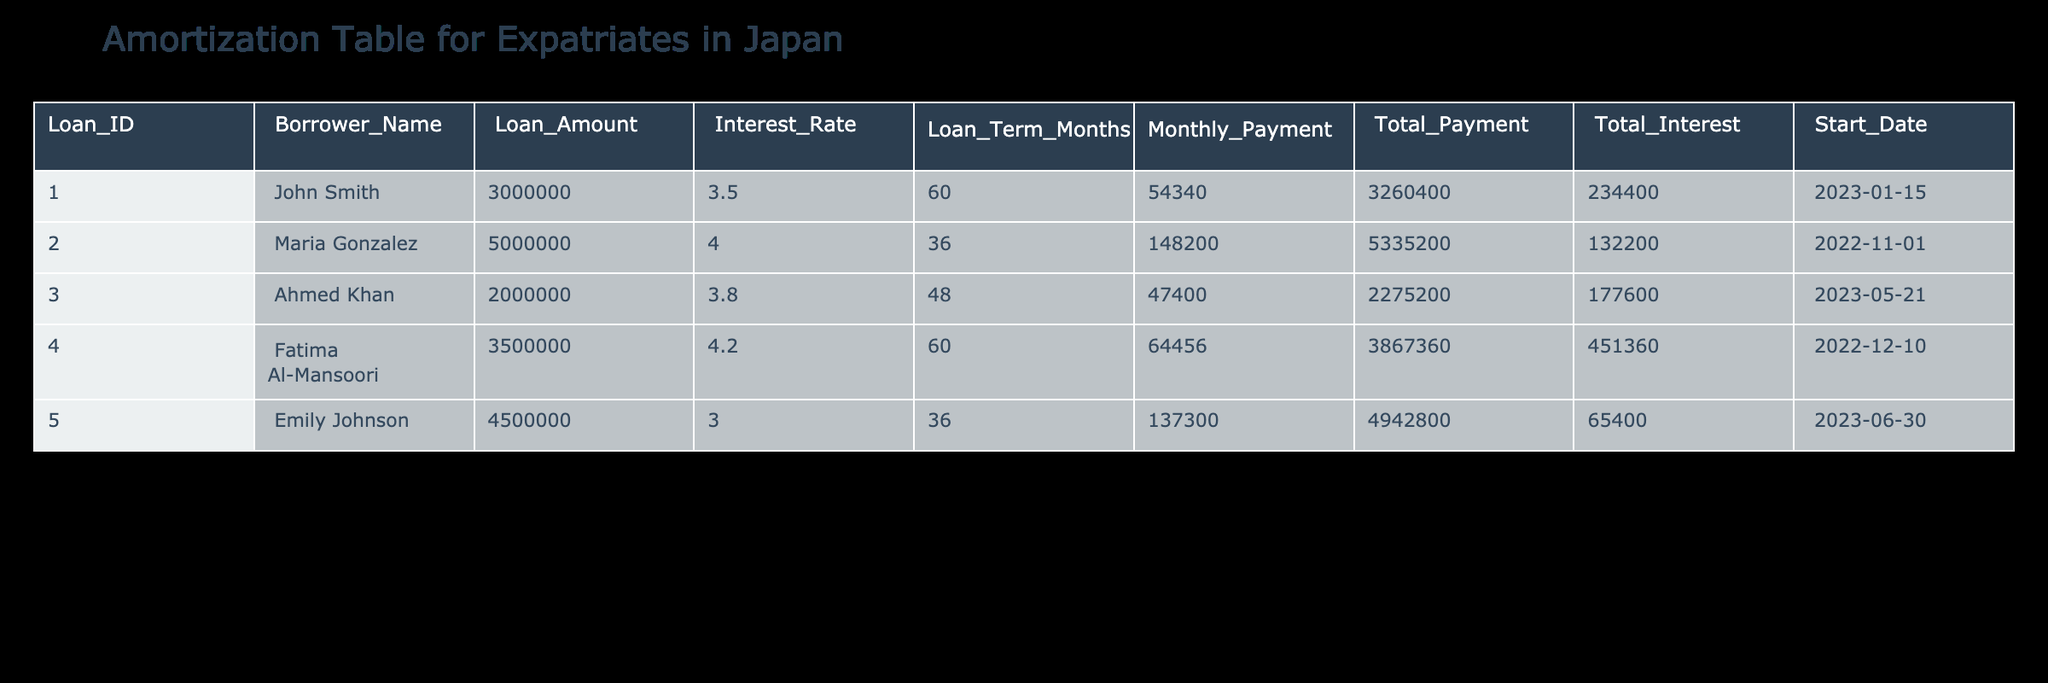What is the loan amount for John Smith? The loan amount for John Smith is directly listed in the table under the "Loan Amount" column next to his name. It shows a value of 3000000.
Answer: 3000000 What is the total interest paid by Maria Gonzalez? Looking at the row for Maria Gonzalez, the total interest is displayed in the "Total Interest" column. The value is 132200.
Answer: 132200 How many months is the loan term for Ahmed Khan? The loan term for Ahmed Khan can be found in the "Loan Term Months" column corresponding to his row in the table. It shows a value of 48 months.
Answer: 48 Which borrower has the highest total payment? To find out who has the highest total payment, I compare the "Total Payment" values in each row. The highest value belongs to Fatima Al-Mansoori, which is 3867360.
Answer: Fatima Al-Mansoori What is the average monthly payment for all borrowers? First, sum all the "Monthly Payment" values together: (54340 + 148200 + 47400 + 64456 + 137300) = 412696. Then divide by the number of borrowers (5), giving us an average of 82539.2.
Answer: 82539.2 Is the interest rate for Emily Johnson lower than 4%? By checking the "Interest Rate" column for Emily Johnson, the value is 3.0%, which is indeed lower than 4%.
Answer: Yes Who has taken a loan for the shortest term? I review the "Loan Term Months" for each borrower. The shortest term listed is 36 months, which belongs to both Maria Gonzalez and Emily Johnson.
Answer: Maria Gonzalez and Emily Johnson What is the total payment difference between John Smith and Fatima Al-Mansoori? I look at the "Total Payment" for both John Smith (3260400) and Fatima Al-Mansoori (3867360). The difference is 3867360 - 3260400 = 607960.
Answer: 607960 How many borrowers have a loan amount greater than 4000000? I review the "Loan Amount" column and count the borrowers with values over 4000000. This includes Maria Gonzalez (5000000), Fatima Al-Mansoori (3500000), and Emily Johnson (4500000). The count is 2.
Answer: 2 